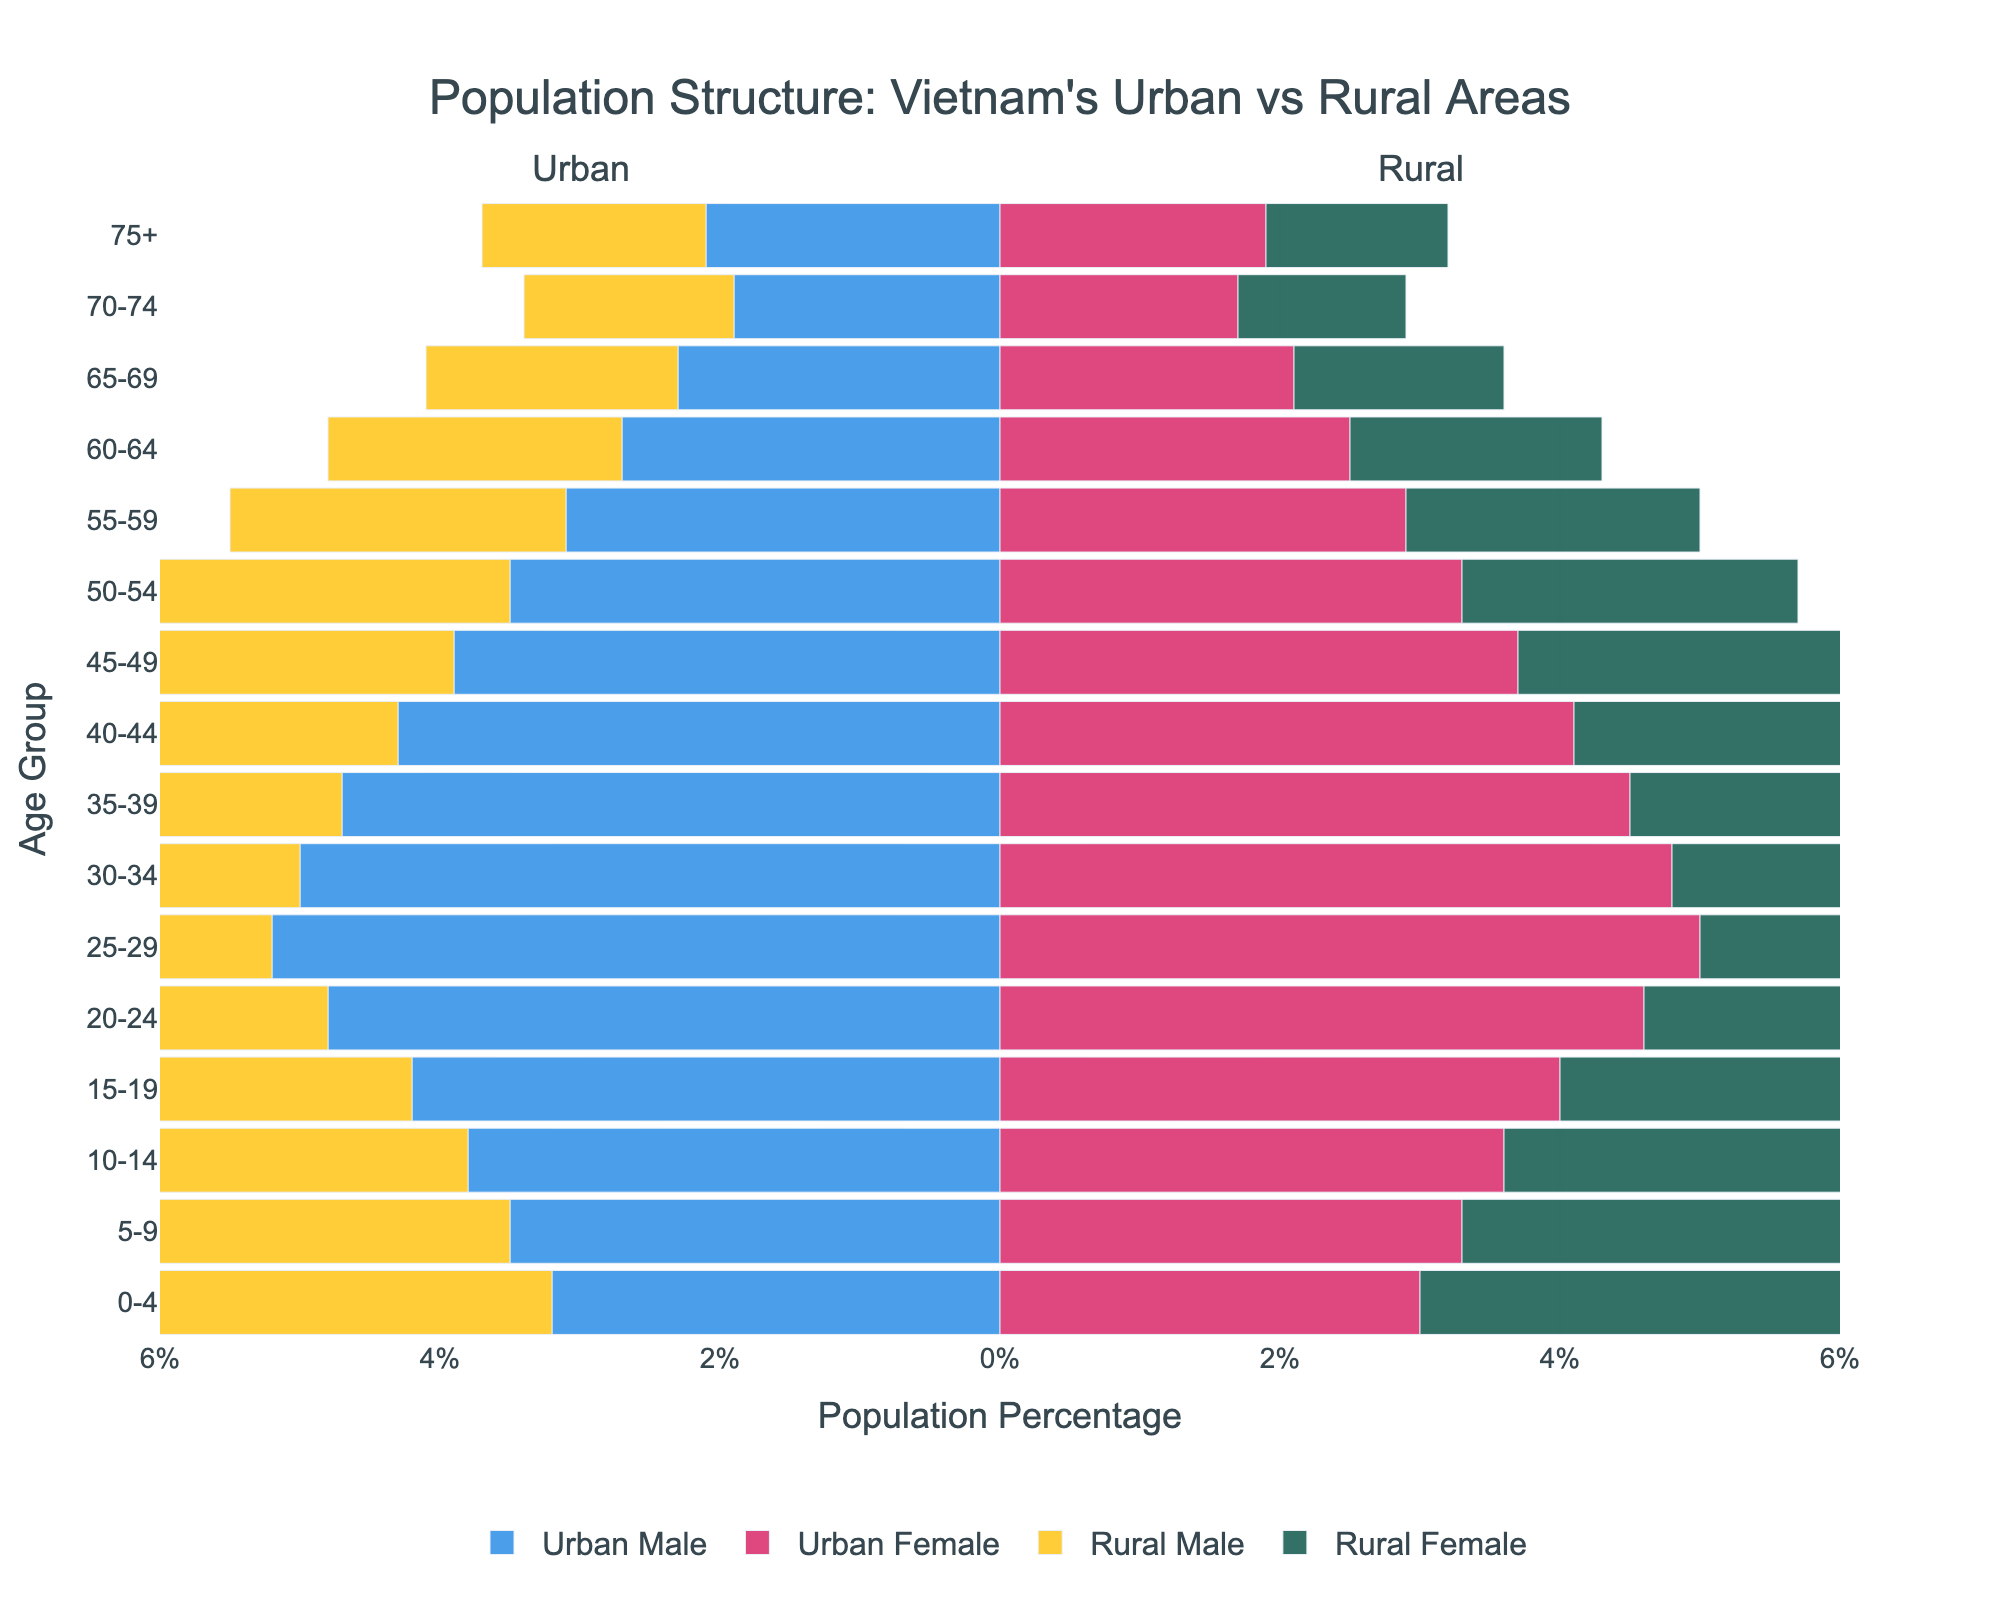What is the most populous age group in urban areas? The most populous age group in urban areas corresponds to the age group with the highest bars for both Urban Male and Urban Female. The age group 25-29 has the highest bars for both genders.
Answer: 25-29 Which age group has a higher percentage of rural females compared to rural males, and what is the percentage difference? First, identify the age groups where the rural female bar is longer than the rural male bar. Then calculate the percentage difference for the chosen age group. For the age group 20-24, rural females are at 4.2% and rural males at 4.5%. Thus, the difference is 4.5% - 4.2% = 0.3%.
Answer: None Compare the 0-4 age group in both urban and rural areas. Which has a higher percentage, and by how much? Look at the bars for the 0-4 age group. Urban males have 3.2% and urban females have 3.0%, whereas rural males have 4.1% and rural females have 3.8%. Both males and females in rural areas are higher. The difference for males is 4.1% - 3.2% = 0.9%. The difference for females is 3.8% - 3.0% = 0.8%. The higher percentage is in rural areas.
Answer: Rural by 0.9% (males) and 0.8% (females) What is the total population percentage for urban males and females within the 15-19 age group? Add the urban male and urban female percentages for the 15-19 age group. Urban males are at 4.2% and urban females at 4.0%. So, the total is 4.2% + 4.0% = 8.2%.
Answer: 8.2% Which age group shows the closest population percentages between urban and rural males? Compare the bars of all age groups for urban and rural males and find the pair with the smallest difference. For the age group 20-24, urban males are at 4.8% and rural males are at 4.5%. The difference is
Answer: 20-24 How does the population structure of the elderly (70-74) differ between urban and rural areas? Look at the 70-74 age group for both urban and rural areas. Urban males are at 1.9%, urban females at 1.7%, rural males at 1.5%, and rural females at 1.2%. Urban areas have higher percentages for both genders.
Answer: Urban areas have higher percentages Which gender in urban areas has the smallest percentage for any single age group, and what is that percentage? Compare all age groups for urban males and females, and identify the smallest percentage. Urban females aged 70-74 have the smallest bar at 1.7%.
Answer: Urban Female, 1.7% What is the overall trend observed among people aged 30-34, comparing urban and rural areas? Observing the bars for the 30-34 age group, urban males are at 5.0%, urban females at 4.8%, rural males at 3.9%, and rural females at 3.6%. The trend shows urban areas have higher percentages in this age group than rural areas.
Answer: Urban areas are higher For the age group 60-64, by what percentage is the rural male population smaller than the urban male population? Identify the percentages for males in the 60-64 age group: urban males at 2.7% and rural males at 2.1%. The difference is 2.7% - 2.1% = 0.6%.
Answer: 0.6% 